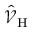<formula> <loc_0><loc_0><loc_500><loc_500>\hat { \mathcal { V } } _ { H }</formula> 